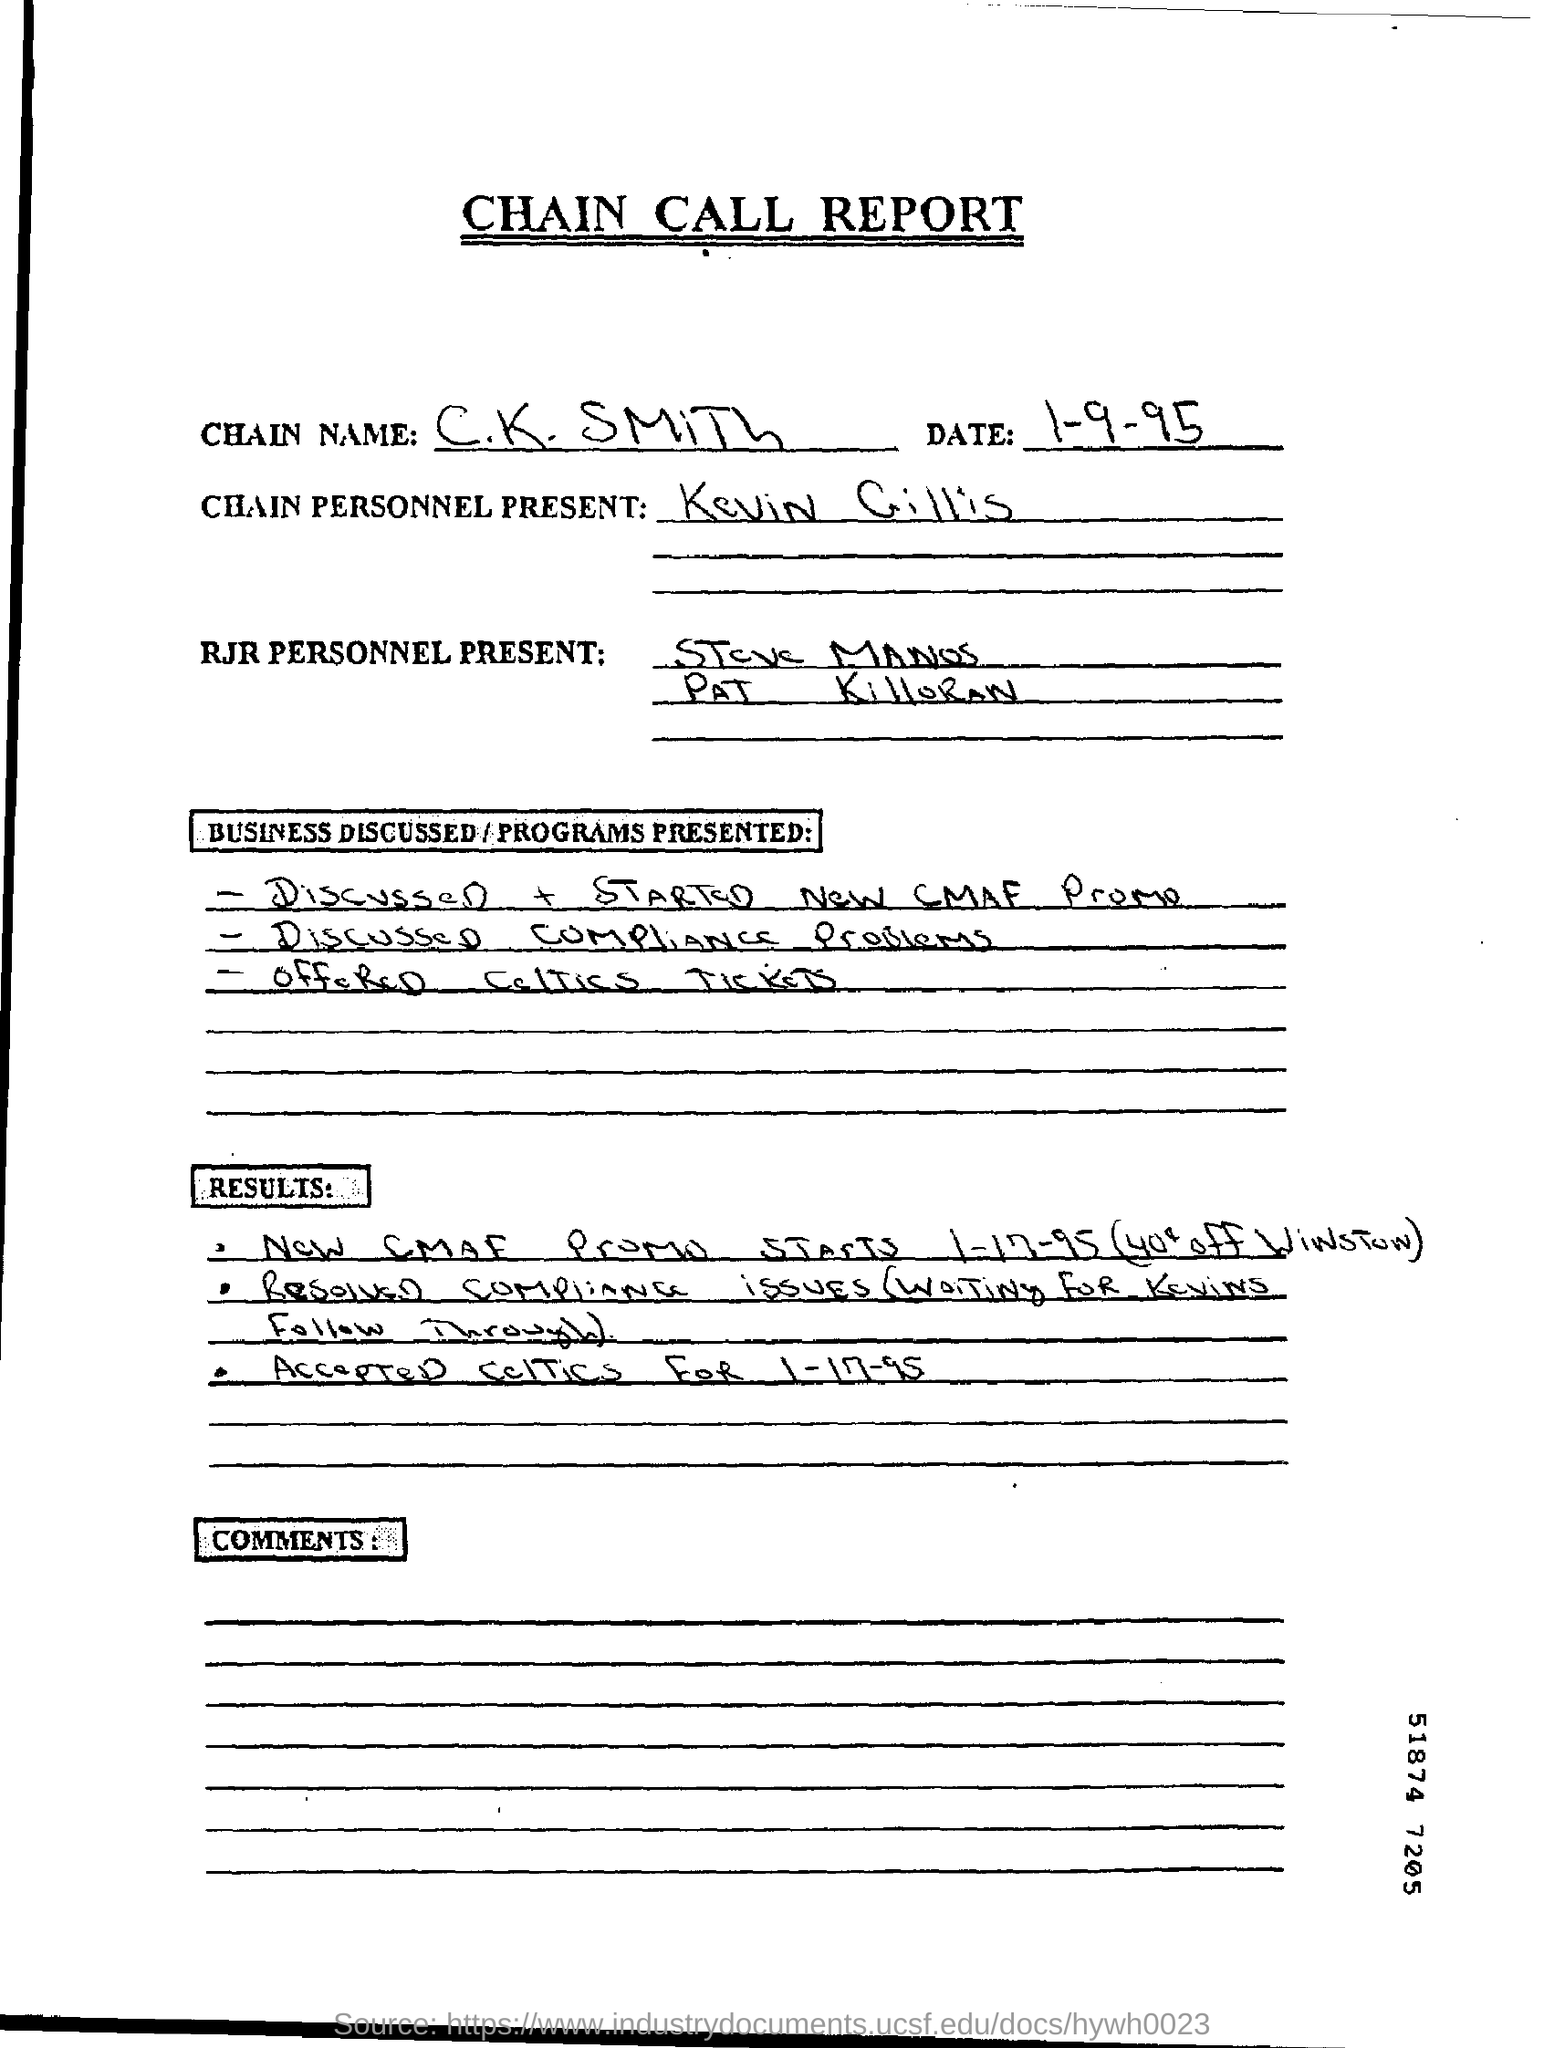List a handful of essential elements in this visual. The report given is called the Chain Call Report. 